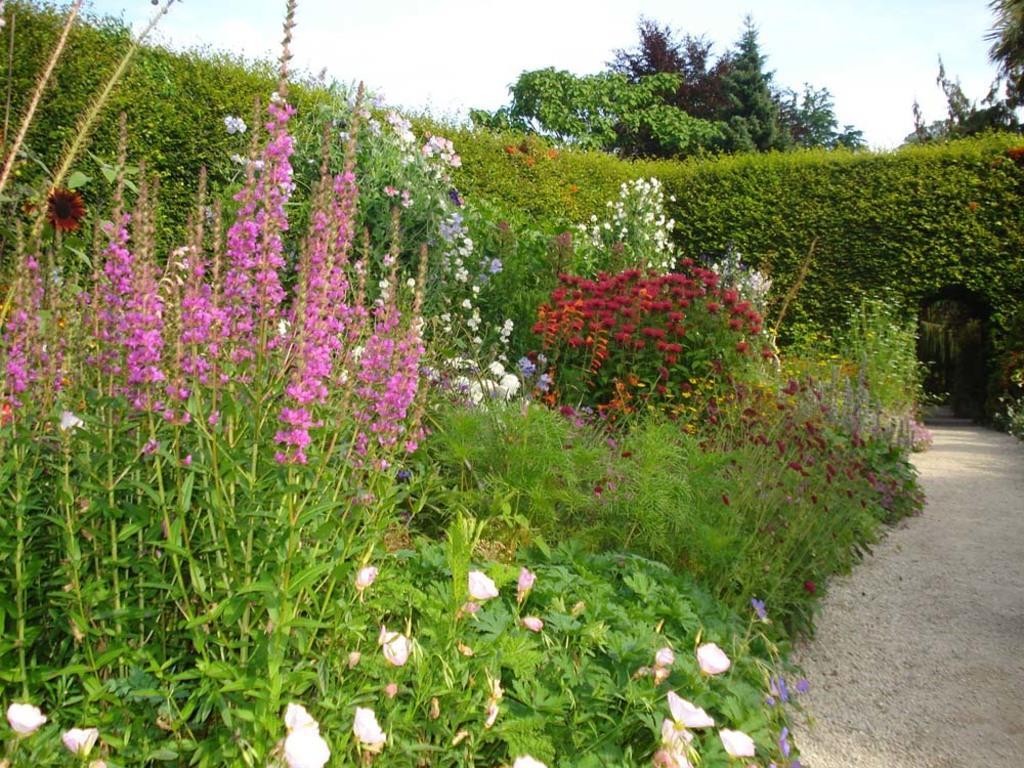Please provide a concise description of this image. In this picture we can see the path, arch, plants with flowers and in the background we can see trees and the sky. 